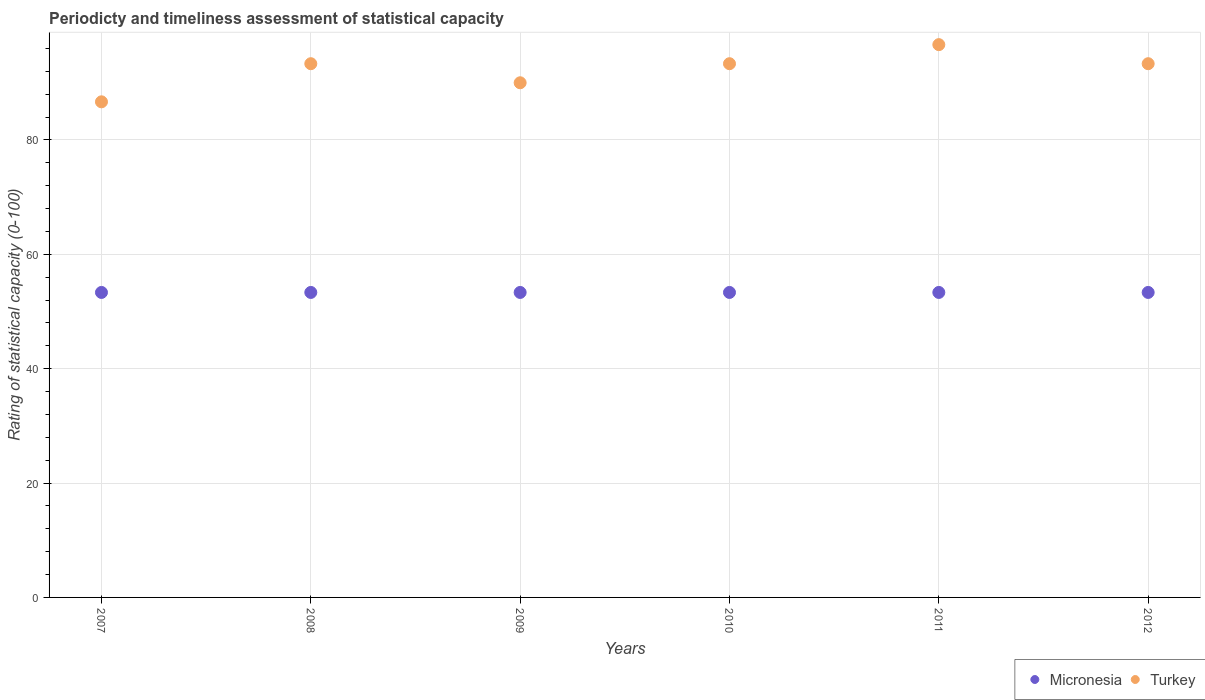How many different coloured dotlines are there?
Provide a short and direct response. 2. What is the rating of statistical capacity in Micronesia in 2009?
Provide a short and direct response. 53.33. Across all years, what is the maximum rating of statistical capacity in Micronesia?
Make the answer very short. 53.33. Across all years, what is the minimum rating of statistical capacity in Micronesia?
Give a very brief answer. 53.33. What is the total rating of statistical capacity in Micronesia in the graph?
Your response must be concise. 320. What is the difference between the rating of statistical capacity in Turkey in 2007 and that in 2011?
Provide a succinct answer. -10. What is the difference between the rating of statistical capacity in Micronesia in 2012 and the rating of statistical capacity in Turkey in 2010?
Offer a terse response. -40. What is the average rating of statistical capacity in Turkey per year?
Keep it short and to the point. 92.22. In the year 2010, what is the difference between the rating of statistical capacity in Micronesia and rating of statistical capacity in Turkey?
Keep it short and to the point. -40. In how many years, is the rating of statistical capacity in Micronesia greater than 80?
Provide a succinct answer. 0. What is the ratio of the rating of statistical capacity in Turkey in 2009 to that in 2012?
Your response must be concise. 0.96. Is the rating of statistical capacity in Micronesia in 2007 less than that in 2010?
Offer a very short reply. No. What is the difference between the highest and the second highest rating of statistical capacity in Turkey?
Your answer should be very brief. 3.33. Does the rating of statistical capacity in Micronesia monotonically increase over the years?
Offer a terse response. No. Is the rating of statistical capacity in Turkey strictly greater than the rating of statistical capacity in Micronesia over the years?
Ensure brevity in your answer.  Yes. Is the rating of statistical capacity in Turkey strictly less than the rating of statistical capacity in Micronesia over the years?
Your answer should be very brief. No. How many dotlines are there?
Give a very brief answer. 2. How many years are there in the graph?
Your answer should be compact. 6. Where does the legend appear in the graph?
Your response must be concise. Bottom right. What is the title of the graph?
Provide a short and direct response. Periodicty and timeliness assessment of statistical capacity. Does "Cuba" appear as one of the legend labels in the graph?
Give a very brief answer. No. What is the label or title of the Y-axis?
Offer a very short reply. Rating of statistical capacity (0-100). What is the Rating of statistical capacity (0-100) in Micronesia in 2007?
Ensure brevity in your answer.  53.33. What is the Rating of statistical capacity (0-100) in Turkey in 2007?
Ensure brevity in your answer.  86.67. What is the Rating of statistical capacity (0-100) of Micronesia in 2008?
Provide a succinct answer. 53.33. What is the Rating of statistical capacity (0-100) of Turkey in 2008?
Your answer should be very brief. 93.33. What is the Rating of statistical capacity (0-100) of Micronesia in 2009?
Your response must be concise. 53.33. What is the Rating of statistical capacity (0-100) in Micronesia in 2010?
Offer a very short reply. 53.33. What is the Rating of statistical capacity (0-100) in Turkey in 2010?
Offer a very short reply. 93.33. What is the Rating of statistical capacity (0-100) of Micronesia in 2011?
Ensure brevity in your answer.  53.33. What is the Rating of statistical capacity (0-100) of Turkey in 2011?
Keep it short and to the point. 96.67. What is the Rating of statistical capacity (0-100) of Micronesia in 2012?
Provide a short and direct response. 53.33. What is the Rating of statistical capacity (0-100) of Turkey in 2012?
Make the answer very short. 93.33. Across all years, what is the maximum Rating of statistical capacity (0-100) in Micronesia?
Keep it short and to the point. 53.33. Across all years, what is the maximum Rating of statistical capacity (0-100) of Turkey?
Your answer should be compact. 96.67. Across all years, what is the minimum Rating of statistical capacity (0-100) of Micronesia?
Make the answer very short. 53.33. Across all years, what is the minimum Rating of statistical capacity (0-100) of Turkey?
Your answer should be compact. 86.67. What is the total Rating of statistical capacity (0-100) of Micronesia in the graph?
Offer a very short reply. 320. What is the total Rating of statistical capacity (0-100) in Turkey in the graph?
Your answer should be compact. 553.33. What is the difference between the Rating of statistical capacity (0-100) of Turkey in 2007 and that in 2008?
Offer a very short reply. -6.67. What is the difference between the Rating of statistical capacity (0-100) of Micronesia in 2007 and that in 2010?
Your answer should be very brief. 0. What is the difference between the Rating of statistical capacity (0-100) of Turkey in 2007 and that in 2010?
Make the answer very short. -6.67. What is the difference between the Rating of statistical capacity (0-100) in Micronesia in 2007 and that in 2011?
Provide a succinct answer. 0. What is the difference between the Rating of statistical capacity (0-100) in Turkey in 2007 and that in 2011?
Your response must be concise. -10. What is the difference between the Rating of statistical capacity (0-100) in Turkey in 2007 and that in 2012?
Your answer should be compact. -6.67. What is the difference between the Rating of statistical capacity (0-100) of Turkey in 2008 and that in 2009?
Make the answer very short. 3.33. What is the difference between the Rating of statistical capacity (0-100) in Micronesia in 2008 and that in 2010?
Offer a very short reply. 0. What is the difference between the Rating of statistical capacity (0-100) of Turkey in 2008 and that in 2010?
Give a very brief answer. 0. What is the difference between the Rating of statistical capacity (0-100) in Micronesia in 2008 and that in 2012?
Offer a terse response. 0. What is the difference between the Rating of statistical capacity (0-100) in Micronesia in 2009 and that in 2011?
Provide a succinct answer. 0. What is the difference between the Rating of statistical capacity (0-100) in Turkey in 2009 and that in 2011?
Offer a terse response. -6.67. What is the difference between the Rating of statistical capacity (0-100) of Turkey in 2009 and that in 2012?
Keep it short and to the point. -3.33. What is the difference between the Rating of statistical capacity (0-100) in Turkey in 2010 and that in 2012?
Offer a terse response. 0. What is the difference between the Rating of statistical capacity (0-100) of Micronesia in 2011 and that in 2012?
Your answer should be very brief. 0. What is the difference between the Rating of statistical capacity (0-100) of Micronesia in 2007 and the Rating of statistical capacity (0-100) of Turkey in 2009?
Give a very brief answer. -36.67. What is the difference between the Rating of statistical capacity (0-100) of Micronesia in 2007 and the Rating of statistical capacity (0-100) of Turkey in 2011?
Keep it short and to the point. -43.33. What is the difference between the Rating of statistical capacity (0-100) in Micronesia in 2008 and the Rating of statistical capacity (0-100) in Turkey in 2009?
Provide a short and direct response. -36.67. What is the difference between the Rating of statistical capacity (0-100) of Micronesia in 2008 and the Rating of statistical capacity (0-100) of Turkey in 2011?
Make the answer very short. -43.33. What is the difference between the Rating of statistical capacity (0-100) in Micronesia in 2008 and the Rating of statistical capacity (0-100) in Turkey in 2012?
Your response must be concise. -40. What is the difference between the Rating of statistical capacity (0-100) of Micronesia in 2009 and the Rating of statistical capacity (0-100) of Turkey in 2011?
Offer a terse response. -43.33. What is the difference between the Rating of statistical capacity (0-100) in Micronesia in 2010 and the Rating of statistical capacity (0-100) in Turkey in 2011?
Your answer should be compact. -43.33. What is the difference between the Rating of statistical capacity (0-100) of Micronesia in 2010 and the Rating of statistical capacity (0-100) of Turkey in 2012?
Provide a succinct answer. -40. What is the difference between the Rating of statistical capacity (0-100) of Micronesia in 2011 and the Rating of statistical capacity (0-100) of Turkey in 2012?
Ensure brevity in your answer.  -40. What is the average Rating of statistical capacity (0-100) in Micronesia per year?
Ensure brevity in your answer.  53.33. What is the average Rating of statistical capacity (0-100) in Turkey per year?
Offer a very short reply. 92.22. In the year 2007, what is the difference between the Rating of statistical capacity (0-100) of Micronesia and Rating of statistical capacity (0-100) of Turkey?
Give a very brief answer. -33.33. In the year 2008, what is the difference between the Rating of statistical capacity (0-100) of Micronesia and Rating of statistical capacity (0-100) of Turkey?
Make the answer very short. -40. In the year 2009, what is the difference between the Rating of statistical capacity (0-100) in Micronesia and Rating of statistical capacity (0-100) in Turkey?
Make the answer very short. -36.67. In the year 2010, what is the difference between the Rating of statistical capacity (0-100) of Micronesia and Rating of statistical capacity (0-100) of Turkey?
Provide a short and direct response. -40. In the year 2011, what is the difference between the Rating of statistical capacity (0-100) in Micronesia and Rating of statistical capacity (0-100) in Turkey?
Offer a terse response. -43.33. What is the ratio of the Rating of statistical capacity (0-100) in Turkey in 2007 to that in 2008?
Ensure brevity in your answer.  0.93. What is the ratio of the Rating of statistical capacity (0-100) in Turkey in 2007 to that in 2009?
Your answer should be very brief. 0.96. What is the ratio of the Rating of statistical capacity (0-100) in Micronesia in 2007 to that in 2010?
Provide a short and direct response. 1. What is the ratio of the Rating of statistical capacity (0-100) of Turkey in 2007 to that in 2010?
Your answer should be very brief. 0.93. What is the ratio of the Rating of statistical capacity (0-100) in Turkey in 2007 to that in 2011?
Make the answer very short. 0.9. What is the ratio of the Rating of statistical capacity (0-100) in Micronesia in 2007 to that in 2012?
Keep it short and to the point. 1. What is the ratio of the Rating of statistical capacity (0-100) in Turkey in 2007 to that in 2012?
Offer a very short reply. 0.93. What is the ratio of the Rating of statistical capacity (0-100) in Turkey in 2008 to that in 2009?
Your answer should be compact. 1.04. What is the ratio of the Rating of statistical capacity (0-100) in Turkey in 2008 to that in 2010?
Your answer should be compact. 1. What is the ratio of the Rating of statistical capacity (0-100) in Micronesia in 2008 to that in 2011?
Offer a terse response. 1. What is the ratio of the Rating of statistical capacity (0-100) in Turkey in 2008 to that in 2011?
Make the answer very short. 0.97. What is the ratio of the Rating of statistical capacity (0-100) in Micronesia in 2009 to that in 2010?
Offer a very short reply. 1. What is the ratio of the Rating of statistical capacity (0-100) of Turkey in 2009 to that in 2010?
Offer a very short reply. 0.96. What is the ratio of the Rating of statistical capacity (0-100) in Micronesia in 2009 to that in 2011?
Provide a short and direct response. 1. What is the ratio of the Rating of statistical capacity (0-100) in Micronesia in 2009 to that in 2012?
Provide a short and direct response. 1. What is the ratio of the Rating of statistical capacity (0-100) in Turkey in 2009 to that in 2012?
Give a very brief answer. 0.96. What is the ratio of the Rating of statistical capacity (0-100) in Micronesia in 2010 to that in 2011?
Offer a very short reply. 1. What is the ratio of the Rating of statistical capacity (0-100) of Turkey in 2010 to that in 2011?
Give a very brief answer. 0.97. What is the ratio of the Rating of statistical capacity (0-100) in Micronesia in 2010 to that in 2012?
Your response must be concise. 1. What is the ratio of the Rating of statistical capacity (0-100) of Turkey in 2010 to that in 2012?
Give a very brief answer. 1. What is the ratio of the Rating of statistical capacity (0-100) in Micronesia in 2011 to that in 2012?
Provide a short and direct response. 1. What is the ratio of the Rating of statistical capacity (0-100) in Turkey in 2011 to that in 2012?
Keep it short and to the point. 1.04. What is the difference between the highest and the second highest Rating of statistical capacity (0-100) of Micronesia?
Your response must be concise. 0. What is the difference between the highest and the second highest Rating of statistical capacity (0-100) in Turkey?
Keep it short and to the point. 3.33. 